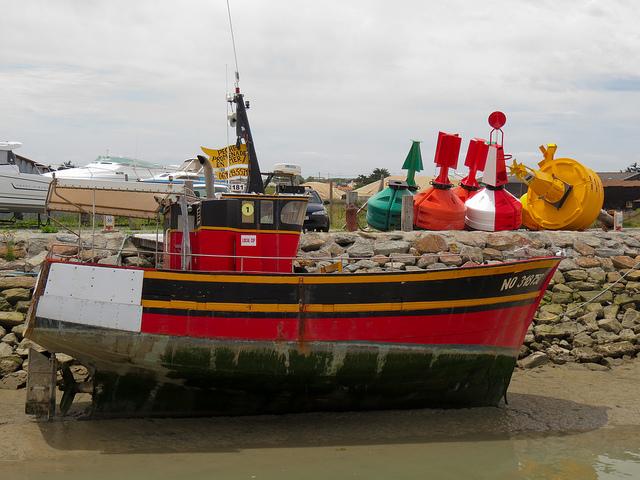Is this boat more than 3 colors?
Quick response, please. Yes. Is this boat real?
Write a very short answer. Yes. How many buoy's are in view?
Concise answer only. 5. Are there birds near the boat?
Concise answer only. No. What is the wall behind the boat made of?
Concise answer only. Stones. 